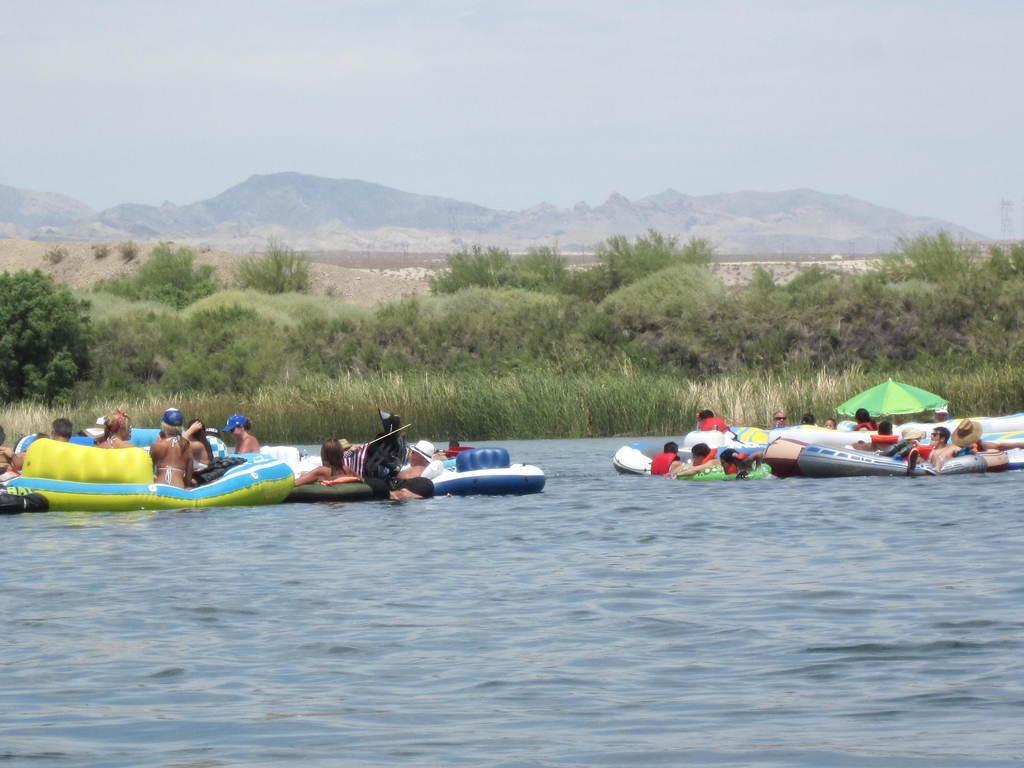How would you summarize this image in a sentence or two? This image consists of many people. They are boating in the tube boats. At the bottom, there is water. In the background, there are many plants and trees along with the mountains. At the top, there are clouds in the sky. 